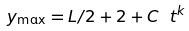<formula> <loc_0><loc_0><loc_500><loc_500>y _ { \max } = L / 2 + 2 + C \ t ^ { k } \,</formula> 